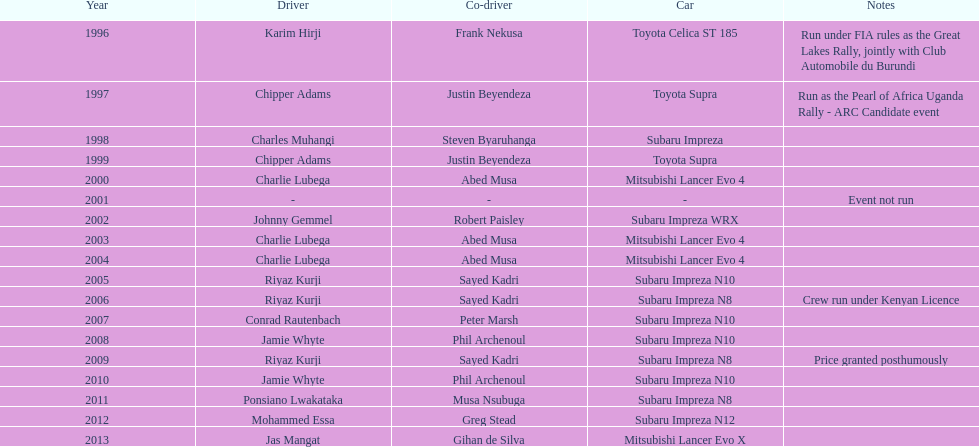In how many instances has the winning driver driven a toyota supra? 2. Write the full table. {'header': ['Year', 'Driver', 'Co-driver', 'Car', 'Notes'], 'rows': [['1996', 'Karim Hirji', 'Frank Nekusa', 'Toyota Celica ST 185', 'Run under FIA rules as the Great Lakes Rally, jointly with Club Automobile du Burundi'], ['1997', 'Chipper Adams', 'Justin Beyendeza', 'Toyota Supra', 'Run as the Pearl of Africa Uganda Rally - ARC Candidate event'], ['1998', 'Charles Muhangi', 'Steven Byaruhanga', 'Subaru Impreza', ''], ['1999', 'Chipper Adams', 'Justin Beyendeza', 'Toyota Supra', ''], ['2000', 'Charlie Lubega', 'Abed Musa', 'Mitsubishi Lancer Evo 4', ''], ['2001', '-', '-', '-', 'Event not run'], ['2002', 'Johnny Gemmel', 'Robert Paisley', 'Subaru Impreza WRX', ''], ['2003', 'Charlie Lubega', 'Abed Musa', 'Mitsubishi Lancer Evo 4', ''], ['2004', 'Charlie Lubega', 'Abed Musa', 'Mitsubishi Lancer Evo 4', ''], ['2005', 'Riyaz Kurji', 'Sayed Kadri', 'Subaru Impreza N10', ''], ['2006', 'Riyaz Kurji', 'Sayed Kadri', 'Subaru Impreza N8', 'Crew run under Kenyan Licence'], ['2007', 'Conrad Rautenbach', 'Peter Marsh', 'Subaru Impreza N10', ''], ['2008', 'Jamie Whyte', 'Phil Archenoul', 'Subaru Impreza N10', ''], ['2009', 'Riyaz Kurji', 'Sayed Kadri', 'Subaru Impreza N8', 'Price granted posthumously'], ['2010', 'Jamie Whyte', 'Phil Archenoul', 'Subaru Impreza N10', ''], ['2011', 'Ponsiano Lwakataka', 'Musa Nsubuga', 'Subaru Impreza N8', ''], ['2012', 'Mohammed Essa', 'Greg Stead', 'Subaru Impreza N12', ''], ['2013', 'Jas Mangat', 'Gihan de Silva', 'Mitsubishi Lancer Evo X', '']]} 